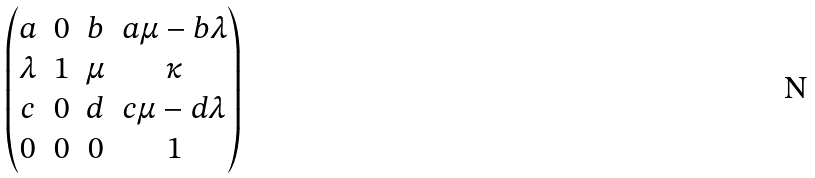Convert formula to latex. <formula><loc_0><loc_0><loc_500><loc_500>\begin{pmatrix} a & 0 & b & a \mu - b \lambda \\ \lambda & 1 & \mu & \kappa \\ c & 0 & d & c \mu - d \lambda \\ 0 & 0 & 0 & 1 \end{pmatrix}</formula> 